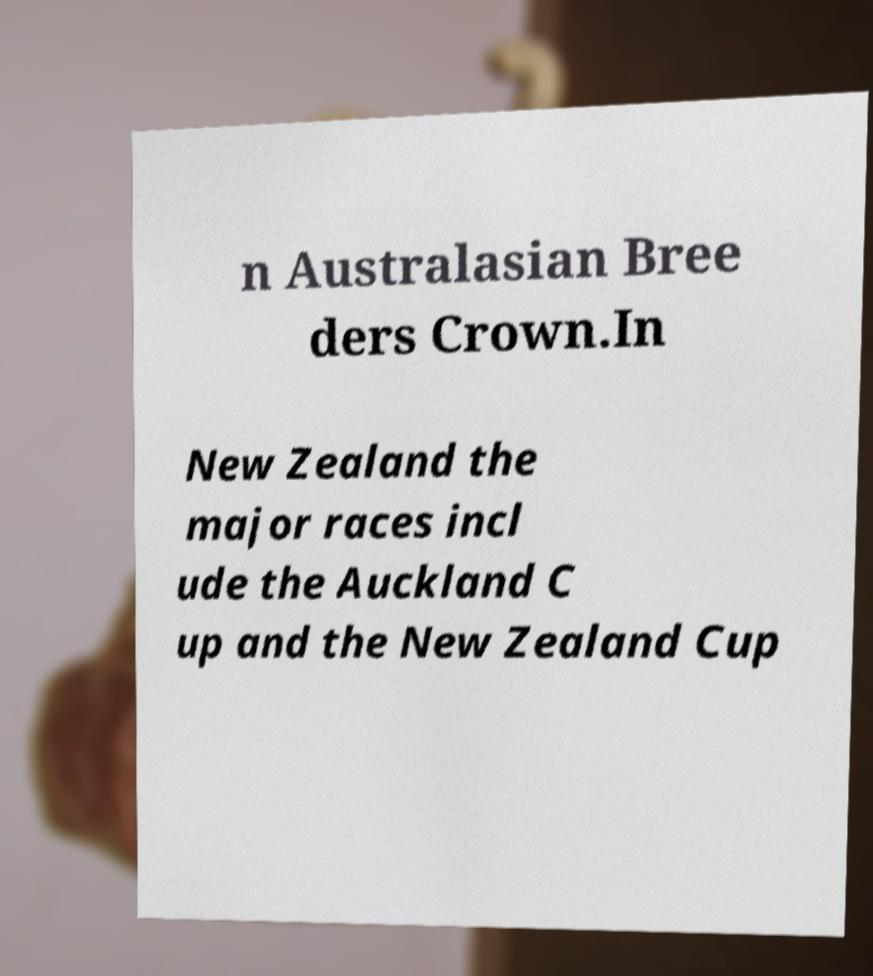What messages or text are displayed in this image? I need them in a readable, typed format. n Australasian Bree ders Crown.In New Zealand the major races incl ude the Auckland C up and the New Zealand Cup 